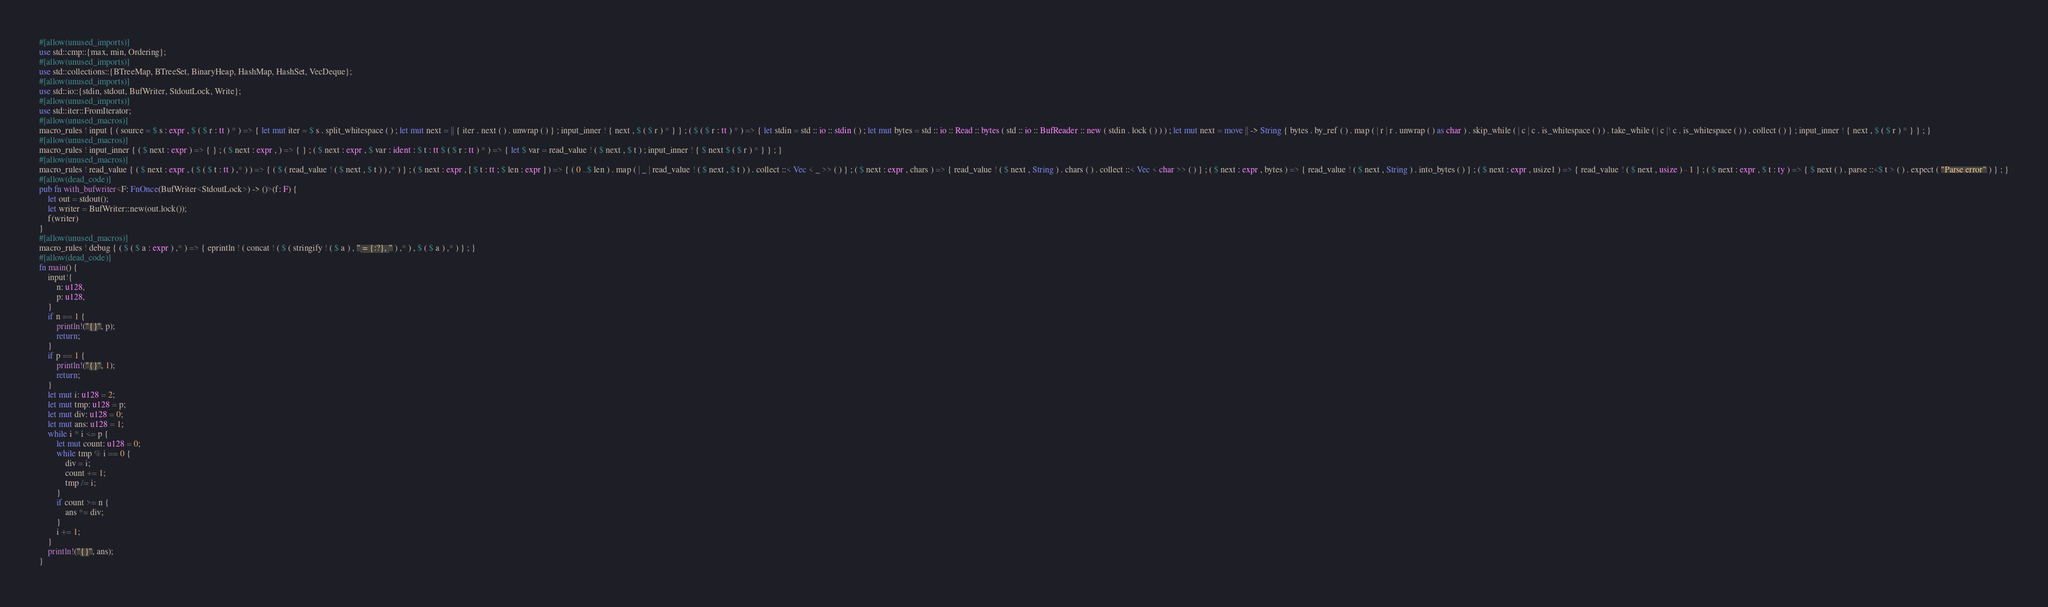Convert code to text. <code><loc_0><loc_0><loc_500><loc_500><_Rust_>#[allow(unused_imports)]
use std::cmp::{max, min, Ordering};
#[allow(unused_imports)]
use std::collections::{BTreeMap, BTreeSet, BinaryHeap, HashMap, HashSet, VecDeque};
#[allow(unused_imports)]
use std::io::{stdin, stdout, BufWriter, StdoutLock, Write};
#[allow(unused_imports)]
use std::iter::FromIterator;
#[allow(unused_macros)]
macro_rules ! input { ( source = $ s : expr , $ ( $ r : tt ) * ) => { let mut iter = $ s . split_whitespace ( ) ; let mut next = || { iter . next ( ) . unwrap ( ) } ; input_inner ! { next , $ ( $ r ) * } } ; ( $ ( $ r : tt ) * ) => { let stdin = std :: io :: stdin ( ) ; let mut bytes = std :: io :: Read :: bytes ( std :: io :: BufReader :: new ( stdin . lock ( ) ) ) ; let mut next = move || -> String { bytes . by_ref ( ) . map ( | r | r . unwrap ( ) as char ) . skip_while ( | c | c . is_whitespace ( ) ) . take_while ( | c |! c . is_whitespace ( ) ) . collect ( ) } ; input_inner ! { next , $ ( $ r ) * } } ; }
#[allow(unused_macros)]
macro_rules ! input_inner { ( $ next : expr ) => { } ; ( $ next : expr , ) => { } ; ( $ next : expr , $ var : ident : $ t : tt $ ( $ r : tt ) * ) => { let $ var = read_value ! ( $ next , $ t ) ; input_inner ! { $ next $ ( $ r ) * } } ; }
#[allow(unused_macros)]
macro_rules ! read_value { ( $ next : expr , ( $ ( $ t : tt ) ,* ) ) => { ( $ ( read_value ! ( $ next , $ t ) ) ,* ) } ; ( $ next : expr , [ $ t : tt ; $ len : expr ] ) => { ( 0 ..$ len ) . map ( | _ | read_value ! ( $ next , $ t ) ) . collect ::< Vec < _ >> ( ) } ; ( $ next : expr , chars ) => { read_value ! ( $ next , String ) . chars ( ) . collect ::< Vec < char >> ( ) } ; ( $ next : expr , bytes ) => { read_value ! ( $ next , String ) . into_bytes ( ) } ; ( $ next : expr , usize1 ) => { read_value ! ( $ next , usize ) - 1 } ; ( $ next : expr , $ t : ty ) => { $ next ( ) . parse ::<$ t > ( ) . expect ( "Parse error" ) } ; }
#[allow(dead_code)]
pub fn with_bufwriter<F: FnOnce(BufWriter<StdoutLock>) -> ()>(f: F) {
    let out = stdout();
    let writer = BufWriter::new(out.lock());
    f(writer)
}
#[allow(unused_macros)]
macro_rules ! debug { ( $ ( $ a : expr ) ,* ) => { eprintln ! ( concat ! ( $ ( stringify ! ( $ a ) , " = {:?}, " ) ,* ) , $ ( $ a ) ,* ) } ; }
#[allow(dead_code)]
fn main() {
    input!{
        n: u128,
        p: u128,
    }
    if n == 1 {
        println!("{}", p);
        return;
    }
    if p == 1 {
        println!("{}", 1);
        return;
    }
    let mut i: u128 = 2;
    let mut tmp: u128 = p;
    let mut div: u128 = 0;
    let mut ans: u128 = 1;
    while i * i <= p {
        let mut count: u128 = 0;
        while tmp % i == 0 {
            div = i;
            count += 1;
            tmp /= i;
        }
        if count >= n {
            ans *= div;
        }
        i += 1;
    }
    println!("{}", ans);
}</code> 